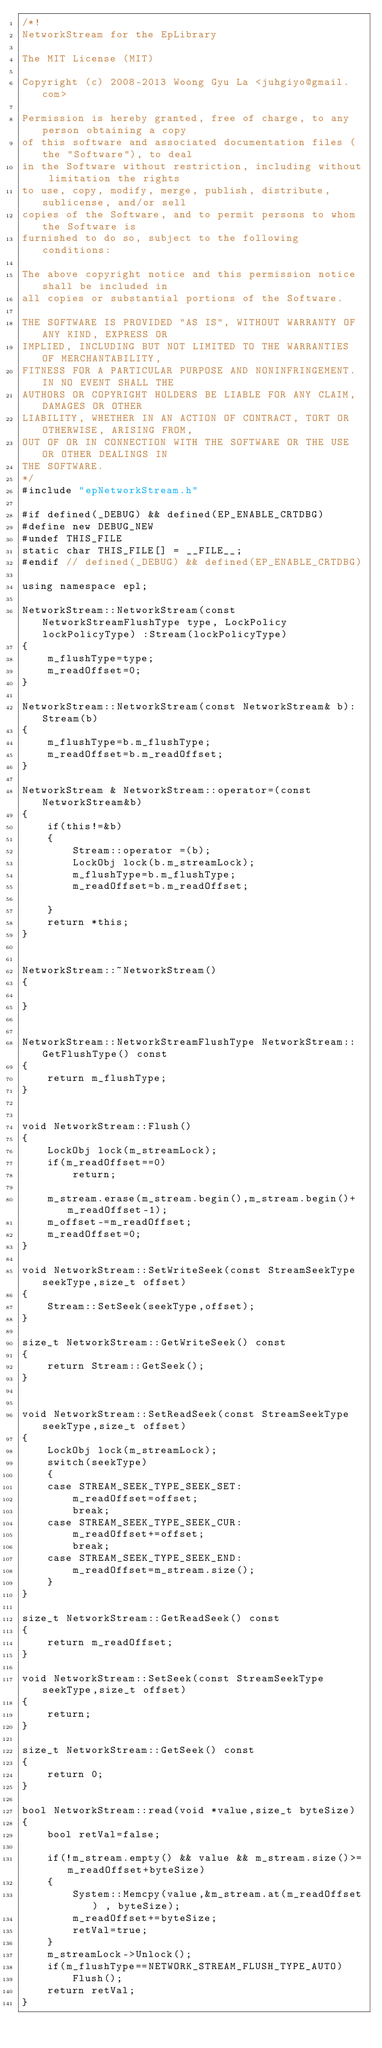<code> <loc_0><loc_0><loc_500><loc_500><_C++_>/*! 
NetworkStream for the EpLibrary

The MIT License (MIT)

Copyright (c) 2008-2013 Woong Gyu La <juhgiyo@gmail.com>

Permission is hereby granted, free of charge, to any person obtaining a copy
of this software and associated documentation files (the "Software"), to deal
in the Software without restriction, including without limitation the rights
to use, copy, modify, merge, publish, distribute, sublicense, and/or sell
copies of the Software, and to permit persons to whom the Software is
furnished to do so, subject to the following conditions:

The above copyright notice and this permission notice shall be included in
all copies or substantial portions of the Software.

THE SOFTWARE IS PROVIDED "AS IS", WITHOUT WARRANTY OF ANY KIND, EXPRESS OR
IMPLIED, INCLUDING BUT NOT LIMITED TO THE WARRANTIES OF MERCHANTABILITY,
FITNESS FOR A PARTICULAR PURPOSE AND NONINFRINGEMENT. IN NO EVENT SHALL THE
AUTHORS OR COPYRIGHT HOLDERS BE LIABLE FOR ANY CLAIM, DAMAGES OR OTHER
LIABILITY, WHETHER IN AN ACTION OF CONTRACT, TORT OR OTHERWISE, ARISING FROM,
OUT OF OR IN CONNECTION WITH THE SOFTWARE OR THE USE OR OTHER DEALINGS IN
THE SOFTWARE.
*/
#include "epNetworkStream.h"

#if defined(_DEBUG) && defined(EP_ENABLE_CRTDBG)
#define new DEBUG_NEW
#undef THIS_FILE
static char THIS_FILE[] = __FILE__;
#endif // defined(_DEBUG) && defined(EP_ENABLE_CRTDBG)

using namespace epl;

NetworkStream::NetworkStream(const NetworkStreamFlushType type, LockPolicy lockPolicyType) :Stream(lockPolicyType)
{
	m_flushType=type;
	m_readOffset=0;
}

NetworkStream::NetworkStream(const NetworkStream& b):Stream(b)
{
	m_flushType=b.m_flushType;
	m_readOffset=b.m_readOffset;
}

NetworkStream & NetworkStream::operator=(const NetworkStream&b)
{
	if(this!=&b)
	{
		Stream::operator =(b);
		LockObj lock(b.m_streamLock);
		m_flushType=b.m_flushType;
		m_readOffset=b.m_readOffset;
		
	}
	return *this;
}


NetworkStream::~NetworkStream()
{

}


NetworkStream::NetworkStreamFlushType NetworkStream::GetFlushType() const
{
	return m_flushType;
}


void NetworkStream::Flush()
{
	LockObj lock(m_streamLock);
	if(m_readOffset==0)
		return;

	m_stream.erase(m_stream.begin(),m_stream.begin()+m_readOffset-1);
	m_offset-=m_readOffset;
	m_readOffset=0;
}

void NetworkStream::SetWriteSeek(const StreamSeekType seekType,size_t offset)
{
	Stream::SetSeek(seekType,offset);
}

size_t NetworkStream::GetWriteSeek() const
{
	return Stream::GetSeek();
}


void NetworkStream::SetReadSeek(const StreamSeekType seekType,size_t offset)
{
	LockObj lock(m_streamLock);
	switch(seekType)
	{
	case STREAM_SEEK_TYPE_SEEK_SET:
		m_readOffset=offset;
		break;
	case STREAM_SEEK_TYPE_SEEK_CUR:
		m_readOffset+=offset;
		break;
	case STREAM_SEEK_TYPE_SEEK_END:
		m_readOffset=m_stream.size();
	}
}

size_t NetworkStream::GetReadSeek() const
{
	return m_readOffset;
}

void NetworkStream::SetSeek(const StreamSeekType seekType,size_t offset)
{
	return;
}

size_t NetworkStream::GetSeek() const
{
	return 0;
}

bool NetworkStream::read(void *value,size_t byteSize)
{
	bool retVal=false;

	if(!m_stream.empty() && value && m_stream.size()>=m_readOffset+byteSize)
	{
		System::Memcpy(value,&m_stream.at(m_readOffset) , byteSize);
		m_readOffset+=byteSize;
		retVal=true;
	}
	m_streamLock->Unlock();	
	if(m_flushType==NETWORK_STREAM_FLUSH_TYPE_AUTO)
		Flush();
	return retVal;
}</code> 